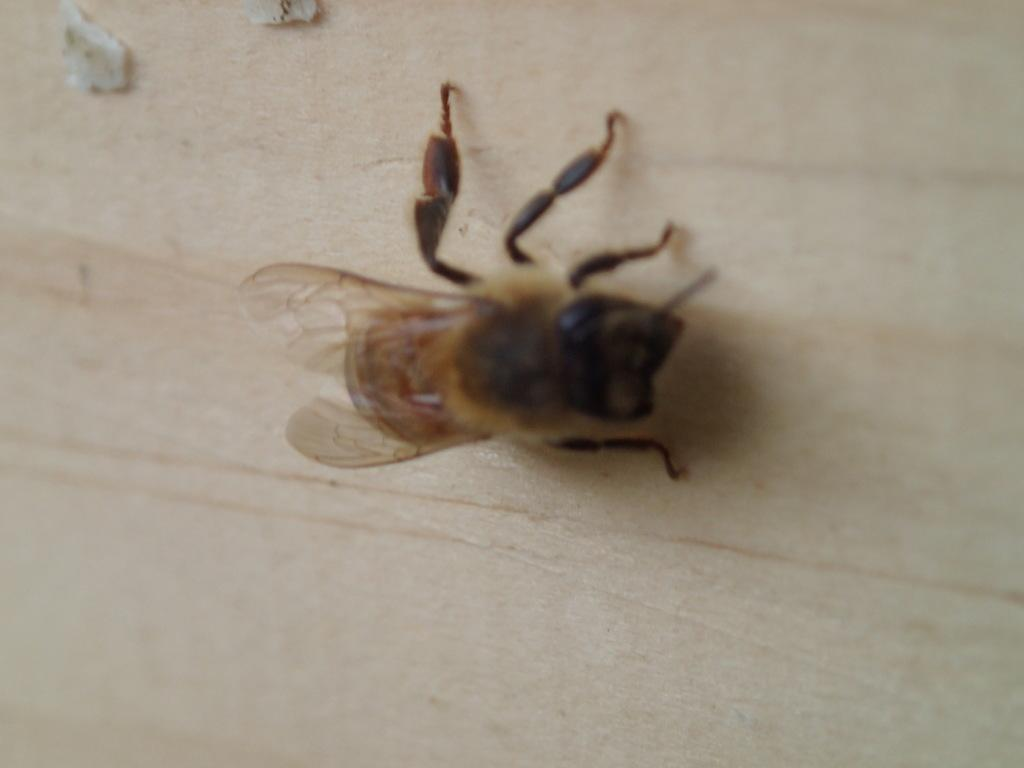What type of creature is present in the image? There is an insect in the image. Where is the insect located in the image? The insect is on a surface. What type of jeans is the insect wearing in the image? There is no indication that the insect is wearing jeans or any clothing in the image. 